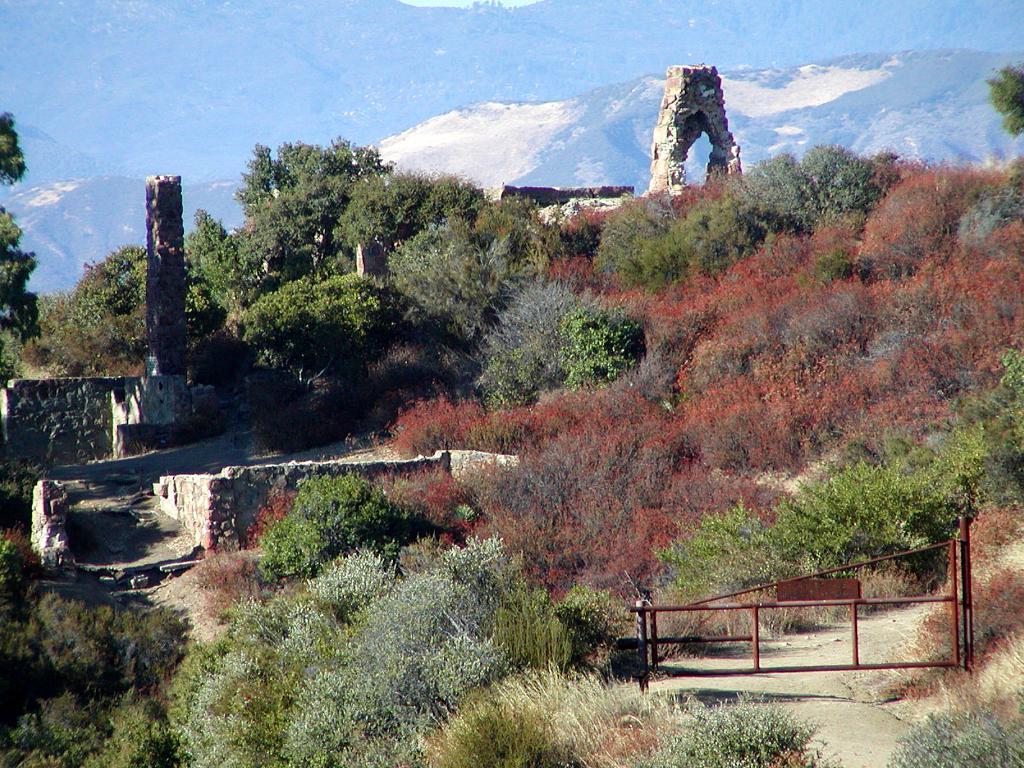How would you summarize this image in a sentence or two? In this image we can see plants, walls, pillar, arch, gate, and trees. In the background we can see mountain. 